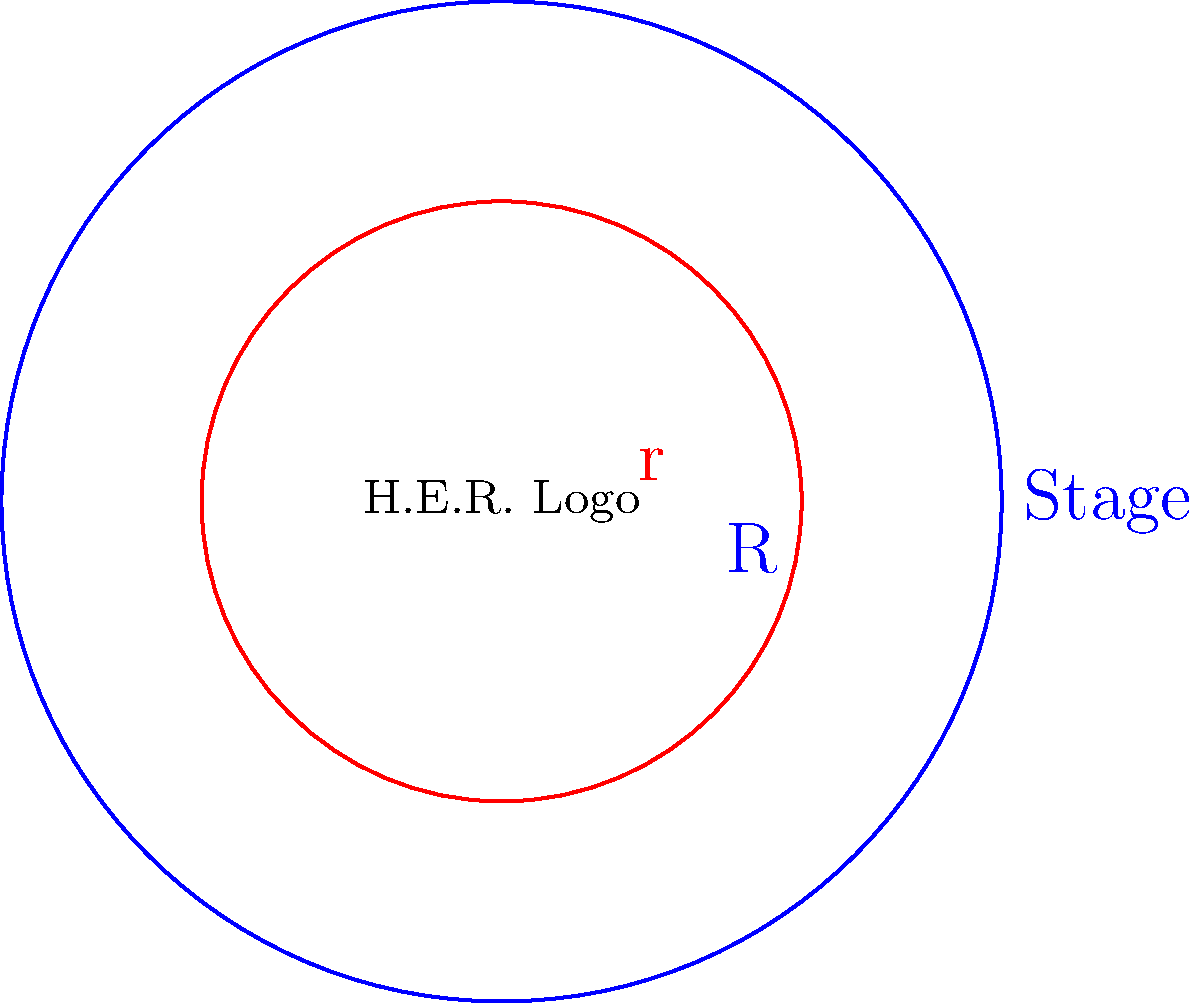H.E.R. is planning a special concert on a circular stage. The stage has a radius of 15 meters, and her iconic logo will be displayed in the center, occupying a circular area with a radius of 9 meters. What is the area of the stage that is not covered by H.E.R.'s logo? Round your answer to the nearest square meter. Let's approach this step-by-step:

1) First, we need to calculate the total area of the stage:
   Area of stage = $\pi R^2$, where $R = 15$ meters
   Area of stage = $\pi (15)^2 = 225\pi$ square meters

2) Next, we calculate the area of H.E.R.'s logo:
   Area of logo = $\pi r^2$, where $r = 9$ meters
   Area of logo = $\pi (9)^2 = 81\pi$ square meters

3) The area we're looking for is the difference between these two areas:
   Area not covered = Area of stage - Area of logo
   Area not covered = $225\pi - 81\pi = 144\pi$ square meters

4) Converting to a numerical value:
   Area not covered = $144\pi \approx 452.39$ square meters

5) Rounding to the nearest square meter:
   Area not covered ≈ 452 square meters
Answer: 452 square meters 